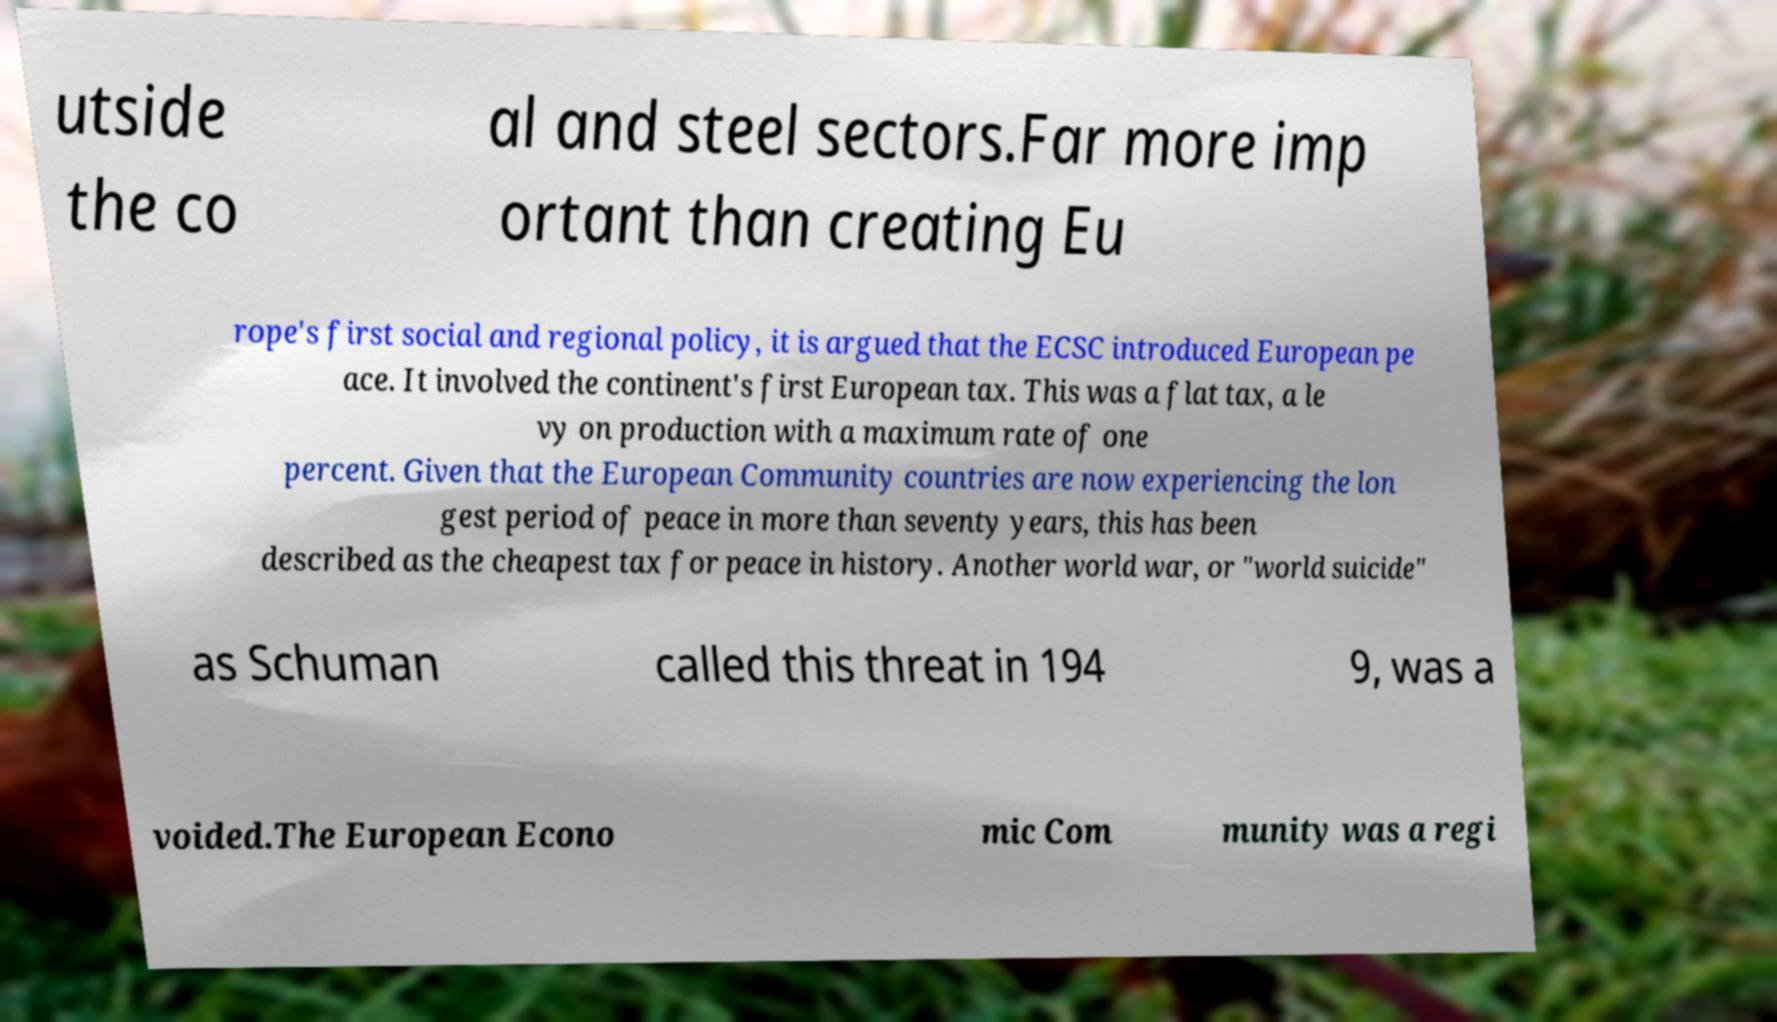What messages or text are displayed in this image? I need them in a readable, typed format. utside the co al and steel sectors.Far more imp ortant than creating Eu rope's first social and regional policy, it is argued that the ECSC introduced European pe ace. It involved the continent's first European tax. This was a flat tax, a le vy on production with a maximum rate of one percent. Given that the European Community countries are now experiencing the lon gest period of peace in more than seventy years, this has been described as the cheapest tax for peace in history. Another world war, or "world suicide" as Schuman called this threat in 194 9, was a voided.The European Econo mic Com munity was a regi 